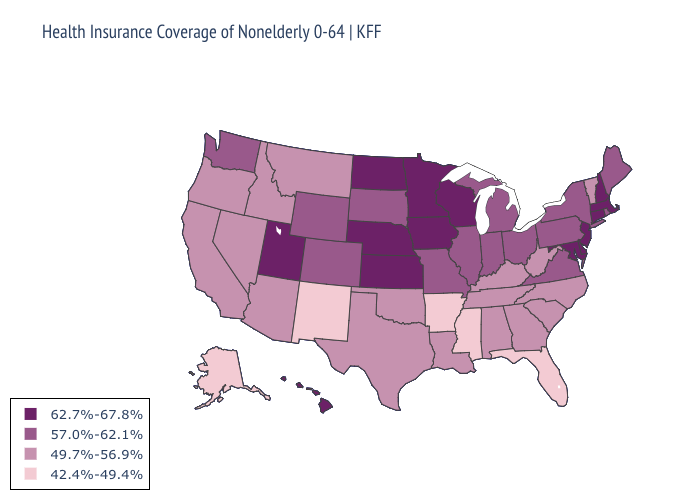Which states have the lowest value in the USA?
Write a very short answer. Alaska, Arkansas, Florida, Mississippi, New Mexico. What is the value of North Dakota?
Write a very short answer. 62.7%-67.8%. Does Texas have the lowest value in the South?
Give a very brief answer. No. Does the map have missing data?
Write a very short answer. No. Does the map have missing data?
Answer briefly. No. What is the value of Mississippi?
Write a very short answer. 42.4%-49.4%. Among the states that border Michigan , does Ohio have the lowest value?
Short answer required. Yes. Among the states that border West Virginia , does Virginia have the lowest value?
Short answer required. No. Which states hav the highest value in the South?
Keep it brief. Delaware, Maryland. Does Louisiana have a lower value than Arkansas?
Answer briefly. No. What is the value of Florida?
Write a very short answer. 42.4%-49.4%. What is the value of Pennsylvania?
Give a very brief answer. 57.0%-62.1%. Name the states that have a value in the range 57.0%-62.1%?
Quick response, please. Colorado, Illinois, Indiana, Maine, Michigan, Missouri, New York, Ohio, Pennsylvania, Rhode Island, South Dakota, Virginia, Washington, Wyoming. 